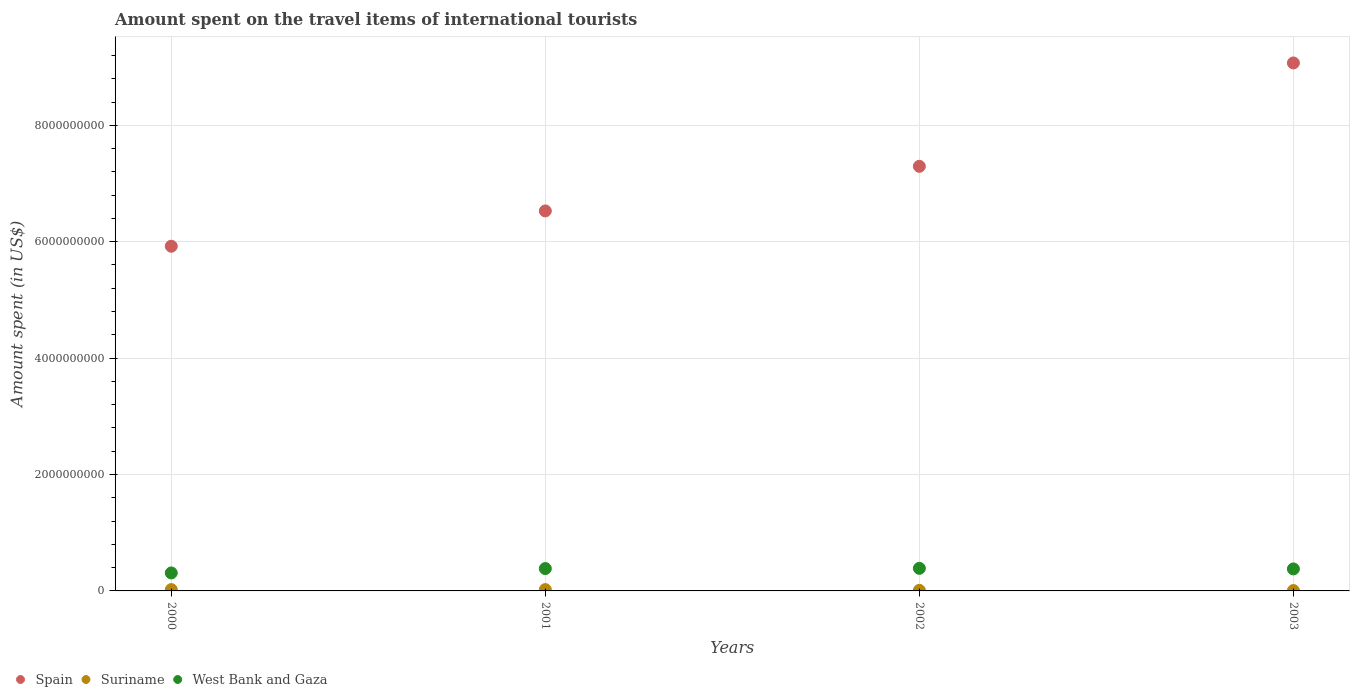What is the amount spent on the travel items of international tourists in West Bank and Gaza in 2001?
Offer a terse response. 3.84e+08. Across all years, what is the maximum amount spent on the travel items of international tourists in West Bank and Gaza?
Ensure brevity in your answer.  3.88e+08. Across all years, what is the minimum amount spent on the travel items of international tourists in West Bank and Gaza?
Give a very brief answer. 3.09e+08. In which year was the amount spent on the travel items of international tourists in West Bank and Gaza maximum?
Ensure brevity in your answer.  2002. What is the total amount spent on the travel items of international tourists in Spain in the graph?
Offer a terse response. 2.88e+1. What is the difference between the amount spent on the travel items of international tourists in West Bank and Gaza in 2000 and that in 2001?
Your response must be concise. -7.50e+07. What is the difference between the amount spent on the travel items of international tourists in West Bank and Gaza in 2002 and the amount spent on the travel items of international tourists in Spain in 2003?
Ensure brevity in your answer.  -8.68e+09. What is the average amount spent on the travel items of international tourists in Suriname per year?
Your answer should be compact. 1.55e+07. In the year 2002, what is the difference between the amount spent on the travel items of international tourists in Spain and amount spent on the travel items of international tourists in Suriname?
Make the answer very short. 7.28e+09. In how many years, is the amount spent on the travel items of international tourists in Spain greater than 2400000000 US$?
Give a very brief answer. 4. What is the ratio of the amount spent on the travel items of international tourists in Suriname in 2000 to that in 2001?
Provide a succinct answer. 1. Is the amount spent on the travel items of international tourists in Suriname in 2000 less than that in 2003?
Your answer should be compact. No. What is the difference between the highest and the lowest amount spent on the travel items of international tourists in Suriname?
Your answer should be compact. 1.70e+07. Does the amount spent on the travel items of international tourists in West Bank and Gaza monotonically increase over the years?
Give a very brief answer. No. Is the amount spent on the travel items of international tourists in Suriname strictly greater than the amount spent on the travel items of international tourists in West Bank and Gaza over the years?
Keep it short and to the point. No. How many dotlines are there?
Give a very brief answer. 3. How many years are there in the graph?
Provide a short and direct response. 4. What is the difference between two consecutive major ticks on the Y-axis?
Your response must be concise. 2.00e+09. Does the graph contain any zero values?
Give a very brief answer. No. Does the graph contain grids?
Offer a terse response. Yes. Where does the legend appear in the graph?
Provide a short and direct response. Bottom left. What is the title of the graph?
Your answer should be very brief. Amount spent on the travel items of international tourists. Does "Lithuania" appear as one of the legend labels in the graph?
Your answer should be compact. No. What is the label or title of the Y-axis?
Ensure brevity in your answer.  Amount spent (in US$). What is the Amount spent (in US$) in Spain in 2000?
Your answer should be very brief. 5.92e+09. What is the Amount spent (in US$) of Suriname in 2000?
Give a very brief answer. 2.30e+07. What is the Amount spent (in US$) of West Bank and Gaza in 2000?
Offer a terse response. 3.09e+08. What is the Amount spent (in US$) in Spain in 2001?
Provide a succinct answer. 6.53e+09. What is the Amount spent (in US$) of Suriname in 2001?
Your answer should be very brief. 2.30e+07. What is the Amount spent (in US$) in West Bank and Gaza in 2001?
Give a very brief answer. 3.84e+08. What is the Amount spent (in US$) of Spain in 2002?
Provide a succinct answer. 7.30e+09. What is the Amount spent (in US$) of West Bank and Gaza in 2002?
Provide a succinct answer. 3.88e+08. What is the Amount spent (in US$) in Spain in 2003?
Provide a short and direct response. 9.07e+09. What is the Amount spent (in US$) in Suriname in 2003?
Provide a succinct answer. 6.00e+06. What is the Amount spent (in US$) of West Bank and Gaza in 2003?
Offer a terse response. 3.78e+08. Across all years, what is the maximum Amount spent (in US$) of Spain?
Offer a terse response. 9.07e+09. Across all years, what is the maximum Amount spent (in US$) in Suriname?
Offer a very short reply. 2.30e+07. Across all years, what is the maximum Amount spent (in US$) in West Bank and Gaza?
Provide a short and direct response. 3.88e+08. Across all years, what is the minimum Amount spent (in US$) of Spain?
Your response must be concise. 5.92e+09. Across all years, what is the minimum Amount spent (in US$) in West Bank and Gaza?
Give a very brief answer. 3.09e+08. What is the total Amount spent (in US$) of Spain in the graph?
Offer a terse response. 2.88e+1. What is the total Amount spent (in US$) in Suriname in the graph?
Your answer should be compact. 6.20e+07. What is the total Amount spent (in US$) in West Bank and Gaza in the graph?
Provide a short and direct response. 1.46e+09. What is the difference between the Amount spent (in US$) of Spain in 2000 and that in 2001?
Offer a very short reply. -6.07e+08. What is the difference between the Amount spent (in US$) in Suriname in 2000 and that in 2001?
Provide a succinct answer. 0. What is the difference between the Amount spent (in US$) of West Bank and Gaza in 2000 and that in 2001?
Offer a terse response. -7.50e+07. What is the difference between the Amount spent (in US$) in Spain in 2000 and that in 2002?
Make the answer very short. -1.37e+09. What is the difference between the Amount spent (in US$) in Suriname in 2000 and that in 2002?
Ensure brevity in your answer.  1.30e+07. What is the difference between the Amount spent (in US$) of West Bank and Gaza in 2000 and that in 2002?
Keep it short and to the point. -7.90e+07. What is the difference between the Amount spent (in US$) of Spain in 2000 and that in 2003?
Provide a succinct answer. -3.15e+09. What is the difference between the Amount spent (in US$) in Suriname in 2000 and that in 2003?
Offer a terse response. 1.70e+07. What is the difference between the Amount spent (in US$) in West Bank and Gaza in 2000 and that in 2003?
Your answer should be very brief. -6.90e+07. What is the difference between the Amount spent (in US$) of Spain in 2001 and that in 2002?
Make the answer very short. -7.66e+08. What is the difference between the Amount spent (in US$) of Suriname in 2001 and that in 2002?
Your response must be concise. 1.30e+07. What is the difference between the Amount spent (in US$) in West Bank and Gaza in 2001 and that in 2002?
Your response must be concise. -4.00e+06. What is the difference between the Amount spent (in US$) of Spain in 2001 and that in 2003?
Offer a very short reply. -2.54e+09. What is the difference between the Amount spent (in US$) of Suriname in 2001 and that in 2003?
Make the answer very short. 1.70e+07. What is the difference between the Amount spent (in US$) in Spain in 2002 and that in 2003?
Make the answer very short. -1.78e+09. What is the difference between the Amount spent (in US$) in Suriname in 2002 and that in 2003?
Provide a succinct answer. 4.00e+06. What is the difference between the Amount spent (in US$) of West Bank and Gaza in 2002 and that in 2003?
Give a very brief answer. 1.00e+07. What is the difference between the Amount spent (in US$) in Spain in 2000 and the Amount spent (in US$) in Suriname in 2001?
Offer a terse response. 5.90e+09. What is the difference between the Amount spent (in US$) of Spain in 2000 and the Amount spent (in US$) of West Bank and Gaza in 2001?
Your response must be concise. 5.54e+09. What is the difference between the Amount spent (in US$) of Suriname in 2000 and the Amount spent (in US$) of West Bank and Gaza in 2001?
Give a very brief answer. -3.61e+08. What is the difference between the Amount spent (in US$) of Spain in 2000 and the Amount spent (in US$) of Suriname in 2002?
Make the answer very short. 5.91e+09. What is the difference between the Amount spent (in US$) of Spain in 2000 and the Amount spent (in US$) of West Bank and Gaza in 2002?
Offer a terse response. 5.53e+09. What is the difference between the Amount spent (in US$) in Suriname in 2000 and the Amount spent (in US$) in West Bank and Gaza in 2002?
Your answer should be compact. -3.65e+08. What is the difference between the Amount spent (in US$) of Spain in 2000 and the Amount spent (in US$) of Suriname in 2003?
Provide a succinct answer. 5.92e+09. What is the difference between the Amount spent (in US$) in Spain in 2000 and the Amount spent (in US$) in West Bank and Gaza in 2003?
Your answer should be very brief. 5.54e+09. What is the difference between the Amount spent (in US$) of Suriname in 2000 and the Amount spent (in US$) of West Bank and Gaza in 2003?
Give a very brief answer. -3.55e+08. What is the difference between the Amount spent (in US$) in Spain in 2001 and the Amount spent (in US$) in Suriname in 2002?
Give a very brief answer. 6.52e+09. What is the difference between the Amount spent (in US$) in Spain in 2001 and the Amount spent (in US$) in West Bank and Gaza in 2002?
Offer a very short reply. 6.14e+09. What is the difference between the Amount spent (in US$) in Suriname in 2001 and the Amount spent (in US$) in West Bank and Gaza in 2002?
Your response must be concise. -3.65e+08. What is the difference between the Amount spent (in US$) in Spain in 2001 and the Amount spent (in US$) in Suriname in 2003?
Keep it short and to the point. 6.52e+09. What is the difference between the Amount spent (in US$) in Spain in 2001 and the Amount spent (in US$) in West Bank and Gaza in 2003?
Make the answer very short. 6.15e+09. What is the difference between the Amount spent (in US$) of Suriname in 2001 and the Amount spent (in US$) of West Bank and Gaza in 2003?
Provide a succinct answer. -3.55e+08. What is the difference between the Amount spent (in US$) in Spain in 2002 and the Amount spent (in US$) in Suriname in 2003?
Ensure brevity in your answer.  7.29e+09. What is the difference between the Amount spent (in US$) of Spain in 2002 and the Amount spent (in US$) of West Bank and Gaza in 2003?
Ensure brevity in your answer.  6.92e+09. What is the difference between the Amount spent (in US$) of Suriname in 2002 and the Amount spent (in US$) of West Bank and Gaza in 2003?
Your answer should be very brief. -3.68e+08. What is the average Amount spent (in US$) in Spain per year?
Your response must be concise. 7.20e+09. What is the average Amount spent (in US$) of Suriname per year?
Your answer should be compact. 1.55e+07. What is the average Amount spent (in US$) in West Bank and Gaza per year?
Keep it short and to the point. 3.65e+08. In the year 2000, what is the difference between the Amount spent (in US$) in Spain and Amount spent (in US$) in Suriname?
Offer a terse response. 5.90e+09. In the year 2000, what is the difference between the Amount spent (in US$) in Spain and Amount spent (in US$) in West Bank and Gaza?
Ensure brevity in your answer.  5.61e+09. In the year 2000, what is the difference between the Amount spent (in US$) in Suriname and Amount spent (in US$) in West Bank and Gaza?
Give a very brief answer. -2.86e+08. In the year 2001, what is the difference between the Amount spent (in US$) in Spain and Amount spent (in US$) in Suriname?
Offer a terse response. 6.51e+09. In the year 2001, what is the difference between the Amount spent (in US$) of Spain and Amount spent (in US$) of West Bank and Gaza?
Make the answer very short. 6.14e+09. In the year 2001, what is the difference between the Amount spent (in US$) in Suriname and Amount spent (in US$) in West Bank and Gaza?
Make the answer very short. -3.61e+08. In the year 2002, what is the difference between the Amount spent (in US$) of Spain and Amount spent (in US$) of Suriname?
Make the answer very short. 7.28e+09. In the year 2002, what is the difference between the Amount spent (in US$) of Spain and Amount spent (in US$) of West Bank and Gaza?
Your answer should be compact. 6.91e+09. In the year 2002, what is the difference between the Amount spent (in US$) of Suriname and Amount spent (in US$) of West Bank and Gaza?
Ensure brevity in your answer.  -3.78e+08. In the year 2003, what is the difference between the Amount spent (in US$) in Spain and Amount spent (in US$) in Suriname?
Your answer should be compact. 9.06e+09. In the year 2003, what is the difference between the Amount spent (in US$) of Spain and Amount spent (in US$) of West Bank and Gaza?
Give a very brief answer. 8.69e+09. In the year 2003, what is the difference between the Amount spent (in US$) of Suriname and Amount spent (in US$) of West Bank and Gaza?
Ensure brevity in your answer.  -3.72e+08. What is the ratio of the Amount spent (in US$) in Spain in 2000 to that in 2001?
Your response must be concise. 0.91. What is the ratio of the Amount spent (in US$) of West Bank and Gaza in 2000 to that in 2001?
Offer a terse response. 0.8. What is the ratio of the Amount spent (in US$) in Spain in 2000 to that in 2002?
Provide a succinct answer. 0.81. What is the ratio of the Amount spent (in US$) in West Bank and Gaza in 2000 to that in 2002?
Your answer should be compact. 0.8. What is the ratio of the Amount spent (in US$) of Spain in 2000 to that in 2003?
Ensure brevity in your answer.  0.65. What is the ratio of the Amount spent (in US$) of Suriname in 2000 to that in 2003?
Make the answer very short. 3.83. What is the ratio of the Amount spent (in US$) in West Bank and Gaza in 2000 to that in 2003?
Your answer should be compact. 0.82. What is the ratio of the Amount spent (in US$) of Spain in 2001 to that in 2002?
Your answer should be very brief. 0.9. What is the ratio of the Amount spent (in US$) of West Bank and Gaza in 2001 to that in 2002?
Offer a terse response. 0.99. What is the ratio of the Amount spent (in US$) in Spain in 2001 to that in 2003?
Your answer should be compact. 0.72. What is the ratio of the Amount spent (in US$) of Suriname in 2001 to that in 2003?
Provide a succinct answer. 3.83. What is the ratio of the Amount spent (in US$) in West Bank and Gaza in 2001 to that in 2003?
Provide a short and direct response. 1.02. What is the ratio of the Amount spent (in US$) of Spain in 2002 to that in 2003?
Provide a succinct answer. 0.8. What is the ratio of the Amount spent (in US$) in West Bank and Gaza in 2002 to that in 2003?
Your answer should be very brief. 1.03. What is the difference between the highest and the second highest Amount spent (in US$) in Spain?
Make the answer very short. 1.78e+09. What is the difference between the highest and the second highest Amount spent (in US$) in Suriname?
Your answer should be very brief. 0. What is the difference between the highest and the lowest Amount spent (in US$) in Spain?
Your response must be concise. 3.15e+09. What is the difference between the highest and the lowest Amount spent (in US$) in Suriname?
Provide a short and direct response. 1.70e+07. What is the difference between the highest and the lowest Amount spent (in US$) of West Bank and Gaza?
Your response must be concise. 7.90e+07. 